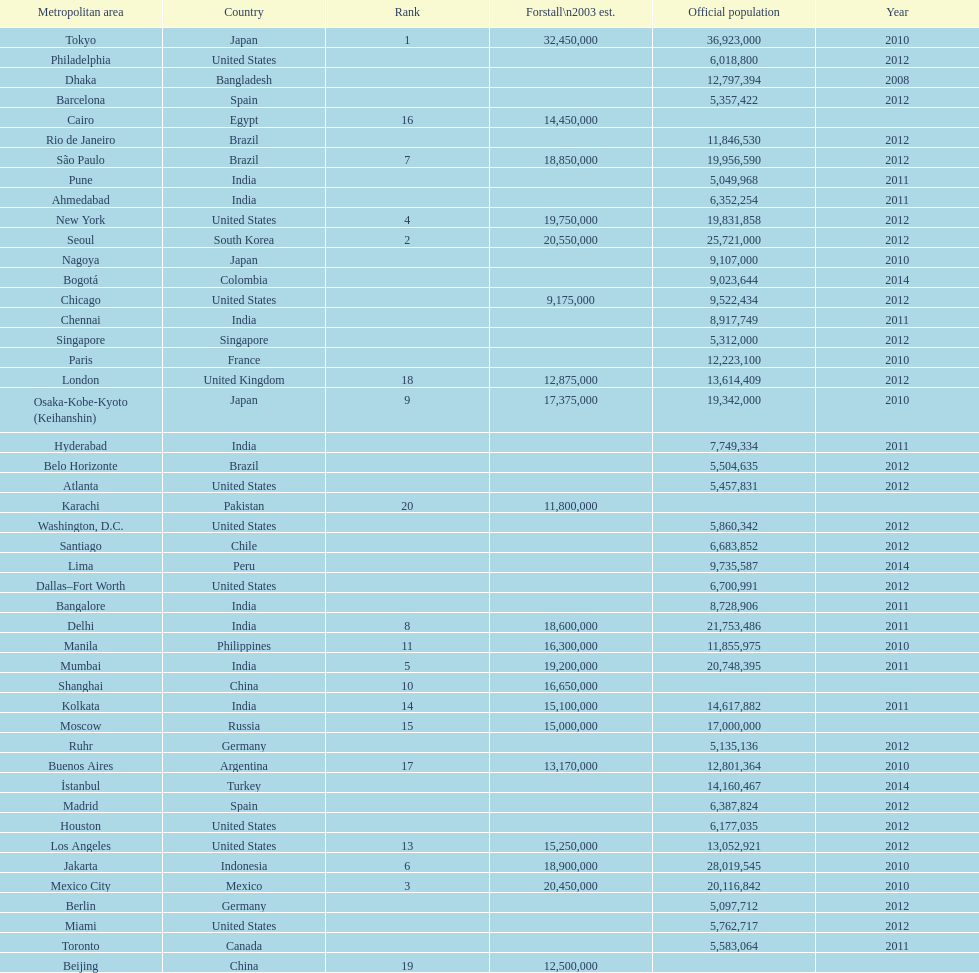Which areas had a population of more than 10,000,000 but less than 20,000,000? Buenos Aires, Dhaka, İstanbul, Kolkata, London, Los Angeles, Manila, Moscow, New York, Osaka-Kobe-Kyoto (Keihanshin), Paris, Rio de Janeiro, São Paulo. 